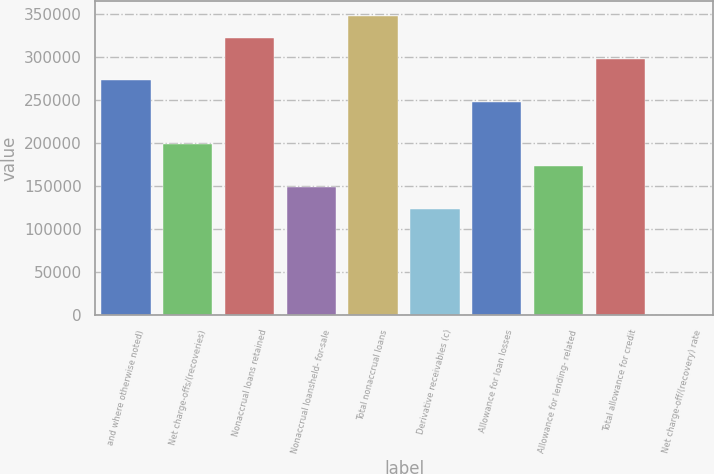<chart> <loc_0><loc_0><loc_500><loc_500><bar_chart><fcel>and where otherwise noted)<fcel>Net charge-offs/(recoveries)<fcel>Nonaccrual loans retained<fcel>Nonaccrual loansheld- for-sale<fcel>Total nonaccrual loans<fcel>Derivative receivables (c)<fcel>Allowance for loan losses<fcel>Allowance for lending- related<fcel>Total allowance for credit<fcel>Net charge-off/(recovery) rate<nl><fcel>273296<fcel>198761<fcel>322986<fcel>149071<fcel>347831<fcel>124226<fcel>248451<fcel>173916<fcel>298141<fcel>0.95<nl></chart> 